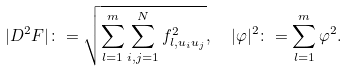<formula> <loc_0><loc_0><loc_500><loc_500>| D ^ { 2 } F | \colon = \sqrt { \sum _ { l = 1 } ^ { m } \sum _ { i , j = 1 } ^ { N } f _ { l , u _ { i } u _ { j } } ^ { 2 } } , \ \ | \varphi | ^ { 2 } \colon = \sum _ { l = 1 } ^ { m } \varphi ^ { 2 } .</formula> 